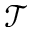Convert formula to latex. <formula><loc_0><loc_0><loc_500><loc_500>\mathcal { T }</formula> 